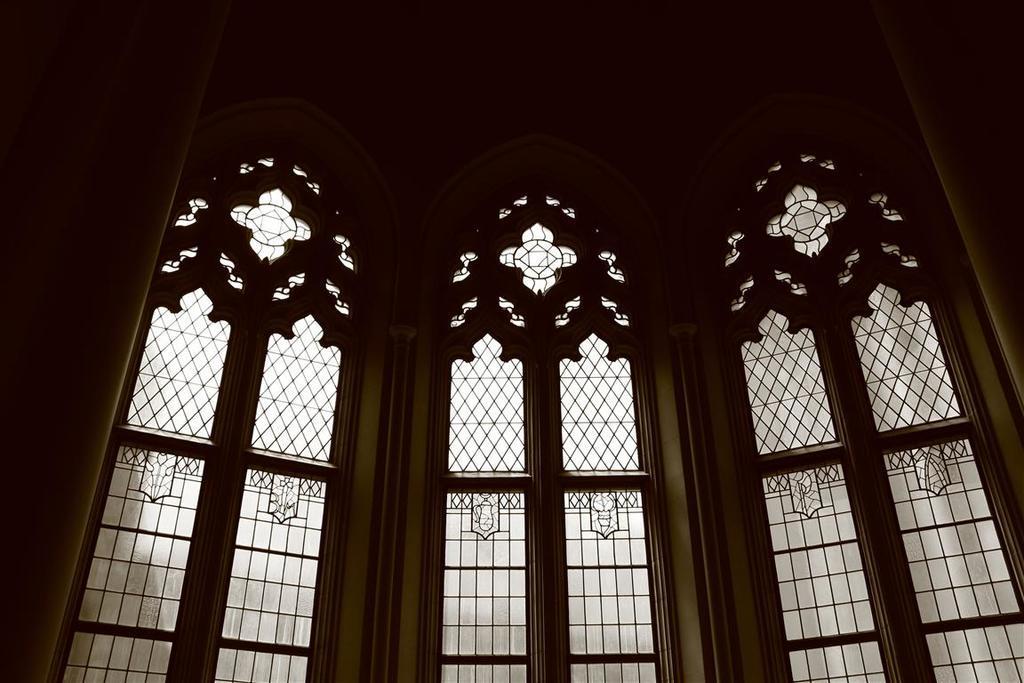Could you give a brief overview of what you see in this image? Here in this picture we can see an inside view of designed windows present on a building over there. 